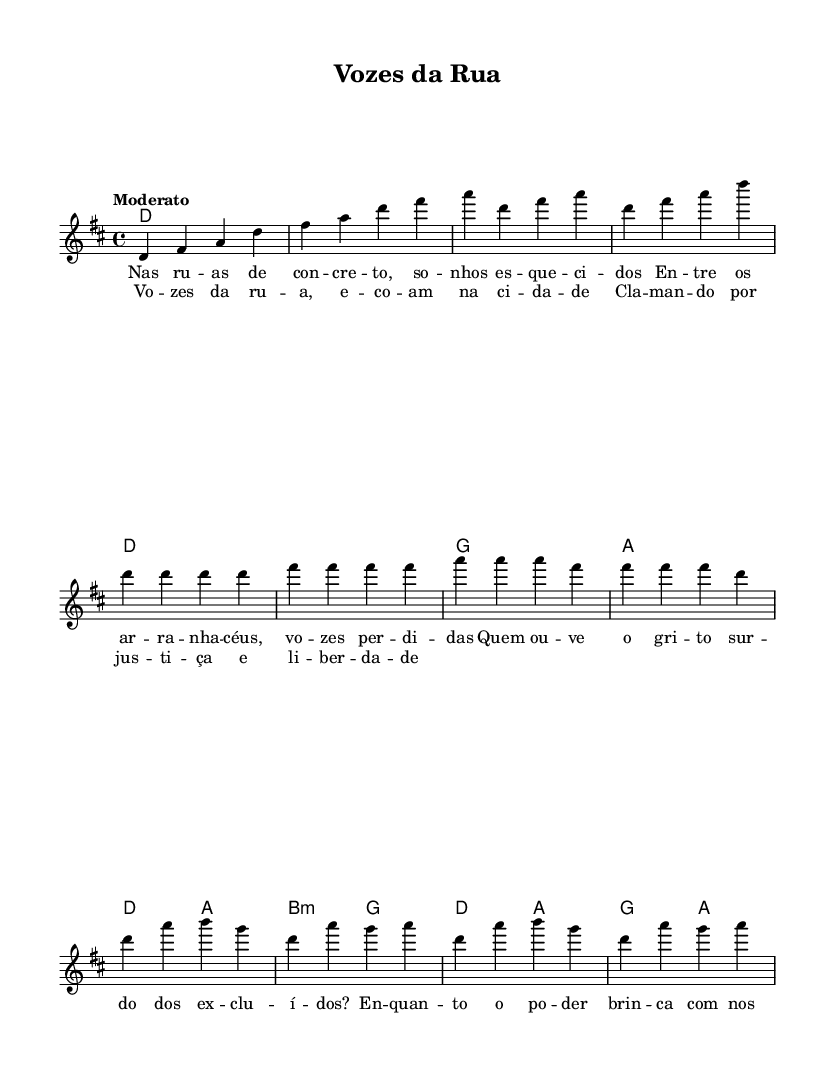What is the key signature of this music? The key signature is indicated at the beginning of the score. From the two sharps shown, it is identified as D major.
Answer: D major What is the time signature of the piece? The time signature is located after the key signature. The 4/4 notation indicates a common time signature used in various forms of music.
Answer: 4/4 What is the tempo marking for this piece? The tempo marking is specified in words, here it is indicated as "Moderato," which suggests a moderate speed.
Answer: Moderato How many measures are in the introductory section? By counting the measures listed in the code for the intro section, which consists of four measures, the total number of measures in the intro can be determined.
Answer: 4 What do the lyrics in the chorus express? The lyrics in the chorus convey themes of justice and freedom. Analyzing the text reveals a call for justice and liberation, reflecting the song's broader social commentary.
Answer: Justice and freedom What is the harmonic structure used in the chorus? By inspecting the chord symbols during the chorus section, we can identify the chords D, A, B minor, G, and A, which create the harmonic foundation.
Answer: D, A, B minor, G, A Which cultural aspects does the song "Vozes da Rua" comment on through its lyrics? By examining the lyrics for social commentary, we find references to social inequality and the struggles of marginalized voices. This reflects the essence of tropicália music, focusing on socio-political themes.
Answer: Social inequality and marginalized voices 